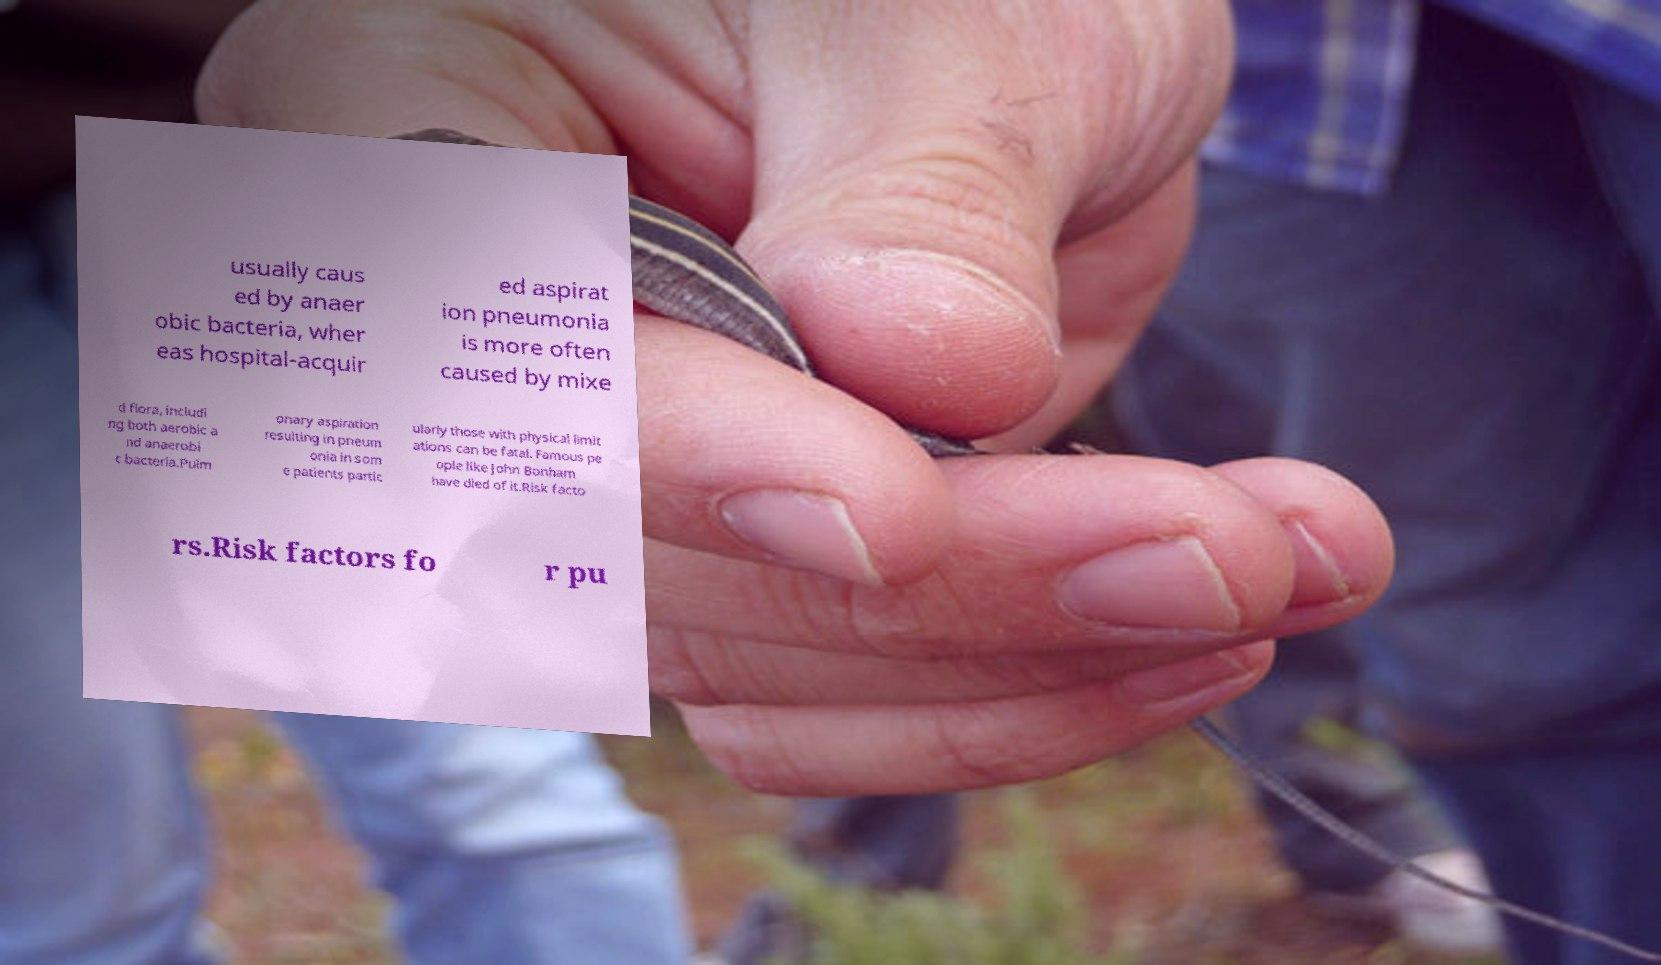For documentation purposes, I need the text within this image transcribed. Could you provide that? usually caus ed by anaer obic bacteria, wher eas hospital-acquir ed aspirat ion pneumonia is more often caused by mixe d flora, includi ng both aerobic a nd anaerobi c bacteria.Pulm onary aspiration resulting in pneum onia in som e patients partic ularly those with physical limit ations can be fatal. Famous pe ople like John Bonham have died of it.Risk facto rs.Risk factors fo r pu 